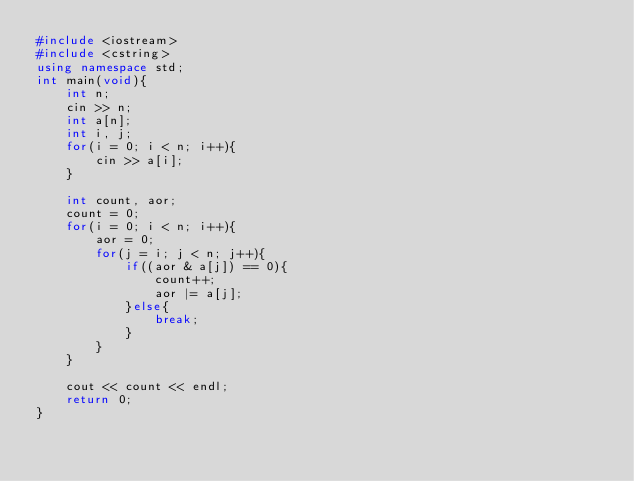Convert code to text. <code><loc_0><loc_0><loc_500><loc_500><_C++_>#include <iostream>
#include <cstring>
using namespace std;
int main(void){
    int n;
    cin >> n;
    int a[n];
    int i, j;
    for(i = 0; i < n; i++){
        cin >> a[i];
    }
    
    int count, aor;
    count = 0;
    for(i = 0; i < n; i++){
        aor = 0;
        for(j = i; j < n; j++){
            if((aor & a[j]) == 0){
                count++;
                aor |= a[j];
            }else{
                break;
            }
        }
    }
    
    cout << count << endl;
    return 0;
}</code> 